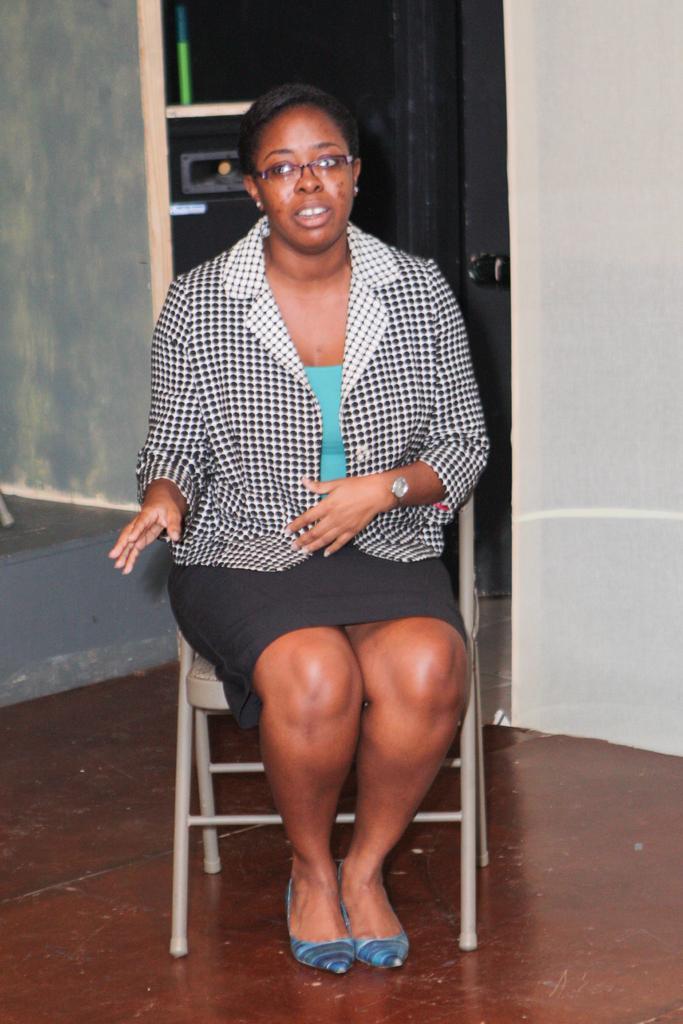Could you give a brief overview of what you see in this image? In this image we can see a women who is wearing black and white blazer, and specs sitting on a chair, behind her we can see a white color wall. 